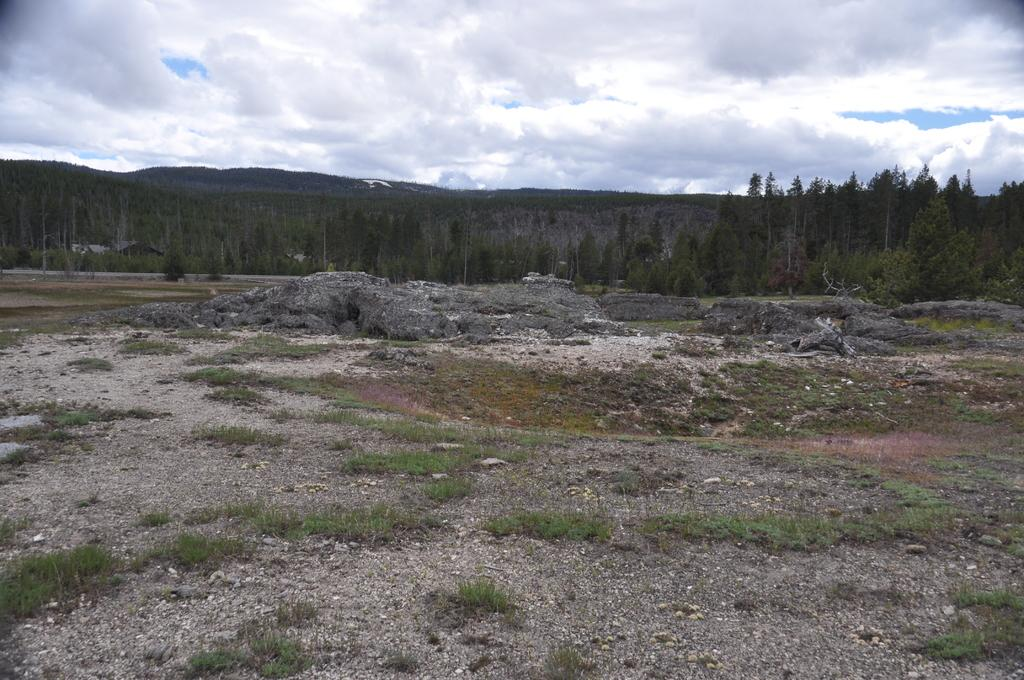What type of terrain is visible in the image? The ground, grass, rocks, trees, and hills are visible in the image. What type of vegetation can be seen in the image? Grass and trees are visible in the image. What type of geological features are present in the image? Rocks and hills are present in the image. What is the condition of the sky in the background? The sky in the background is cloudy. What flavor of ice cream is being served in the hall in the image? There is no ice cream or hall present in the image; it features a landscape with terrain, vegetation, geological features, and a cloudy sky. 